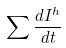Convert formula to latex. <formula><loc_0><loc_0><loc_500><loc_500>\sum \frac { d I ^ { h } } { d t }</formula> 